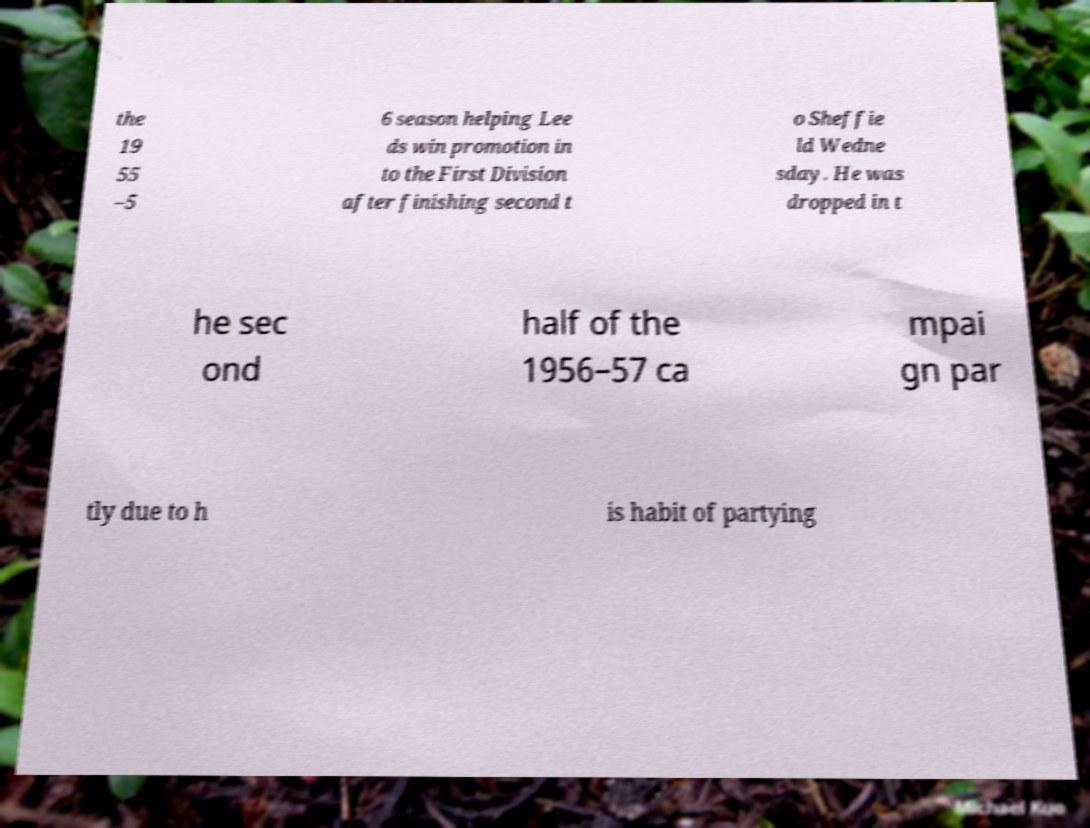Can you accurately transcribe the text from the provided image for me? the 19 55 –5 6 season helping Lee ds win promotion in to the First Division after finishing second t o Sheffie ld Wedne sday. He was dropped in t he sec ond half of the 1956–57 ca mpai gn par tly due to h is habit of partying 